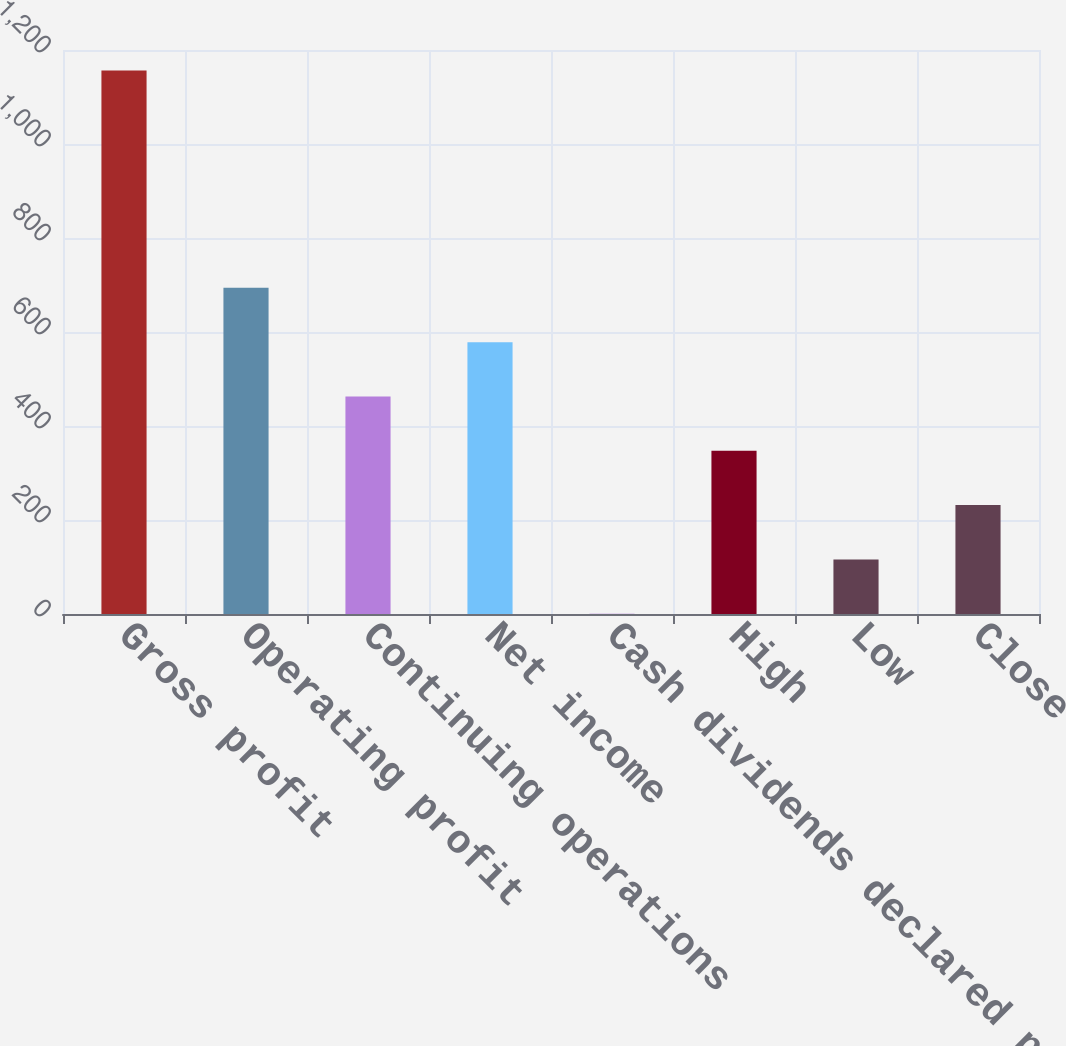<chart> <loc_0><loc_0><loc_500><loc_500><bar_chart><fcel>Gross profit<fcel>Operating profit<fcel>Continuing operations<fcel>Net income<fcel>Cash dividends declared per<fcel>High<fcel>Low<fcel>Close<nl><fcel>1156.4<fcel>694.05<fcel>462.85<fcel>578.45<fcel>0.45<fcel>347.25<fcel>116.05<fcel>231.65<nl></chart> 